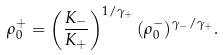Convert formula to latex. <formula><loc_0><loc_0><loc_500><loc_500>\rho _ { 0 } ^ { + } = \left ( \frac { K _ { - } } { K _ { + } } \right ) ^ { 1 / \gamma _ { + } } ( \rho _ { 0 } ^ { - } ) ^ { \gamma _ { - } / \gamma _ { + } } .</formula> 